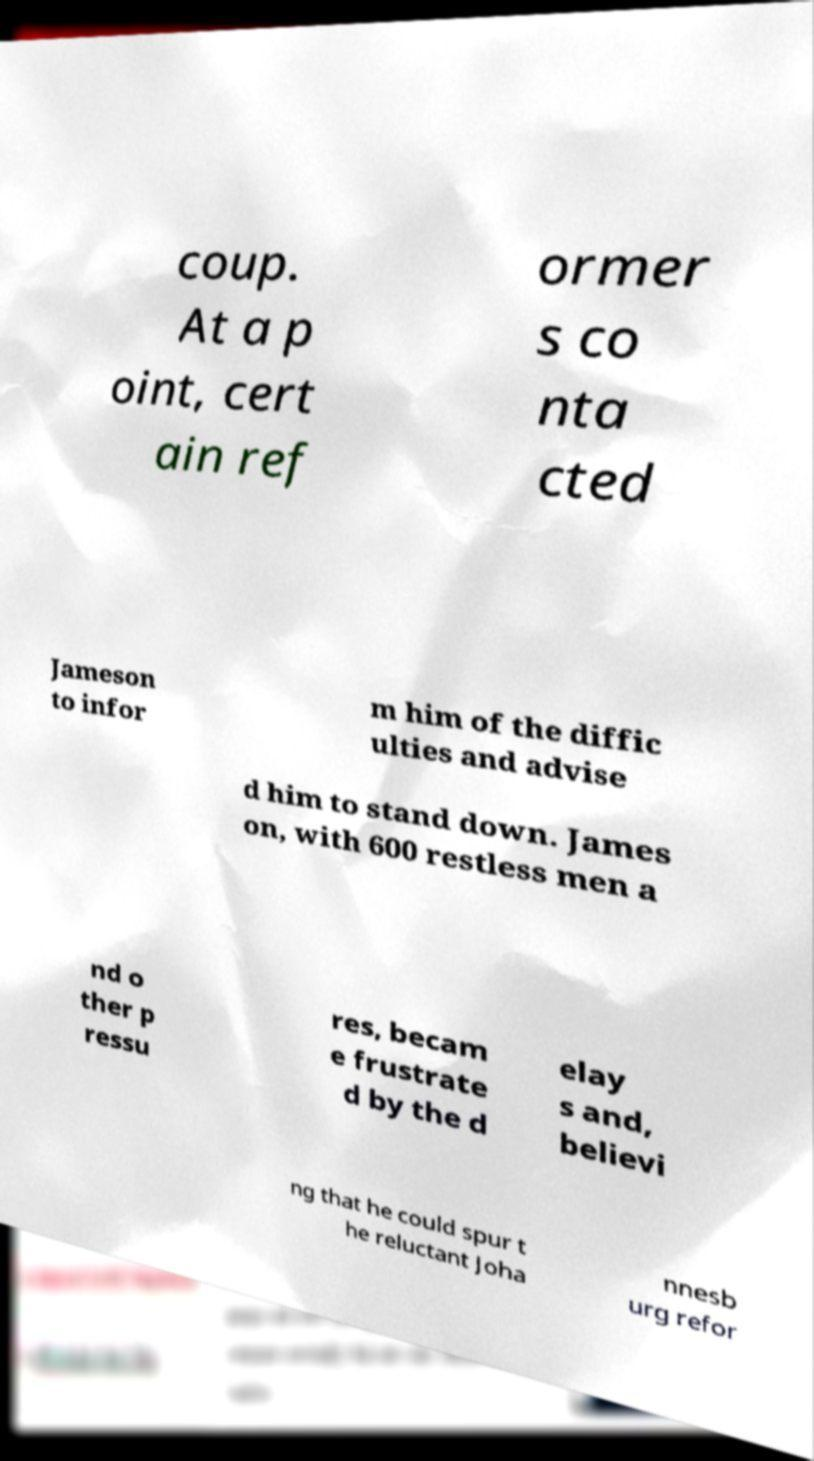There's text embedded in this image that I need extracted. Can you transcribe it verbatim? coup. At a p oint, cert ain ref ormer s co nta cted Jameson to infor m him of the diffic ulties and advise d him to stand down. James on, with 600 restless men a nd o ther p ressu res, becam e frustrate d by the d elay s and, believi ng that he could spur t he reluctant Joha nnesb urg refor 